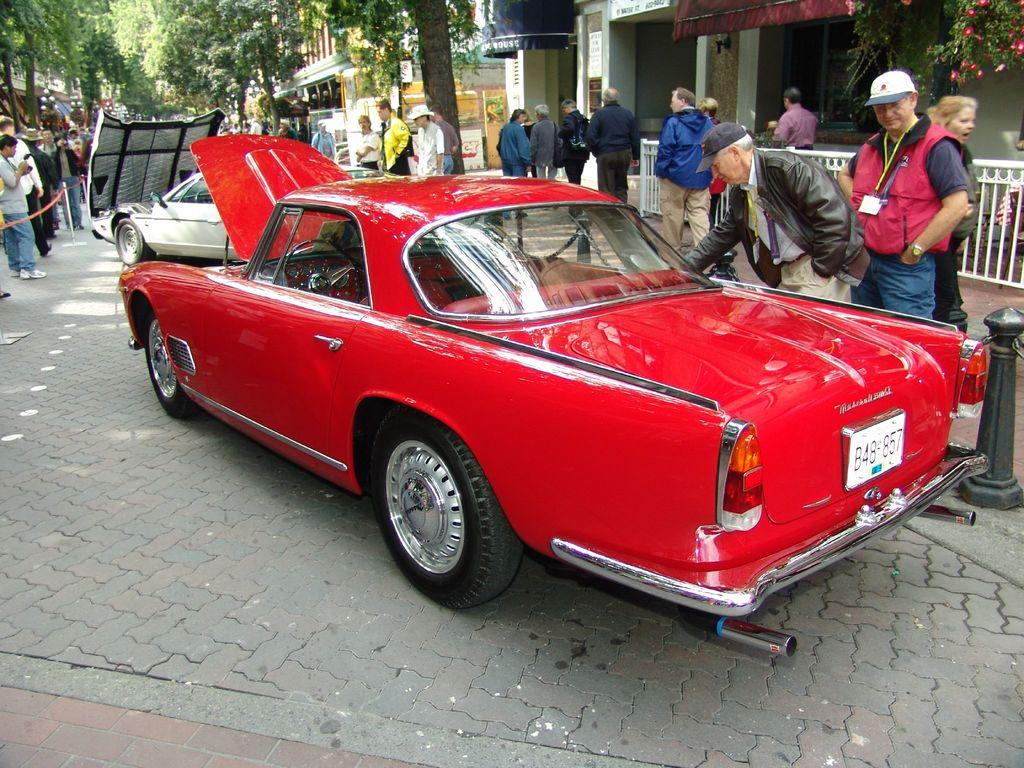What is the main subject in the center of the image? There are cars on the road in the center of the image. What can be seen in the background of the image? There are persons visible in the background, as well as trees and buildings. What type of sugar is being used to decorate the toys in the image? There are no toys or sugar present in the image; it features cars on the road and persons, trees, and buildings in the background. 